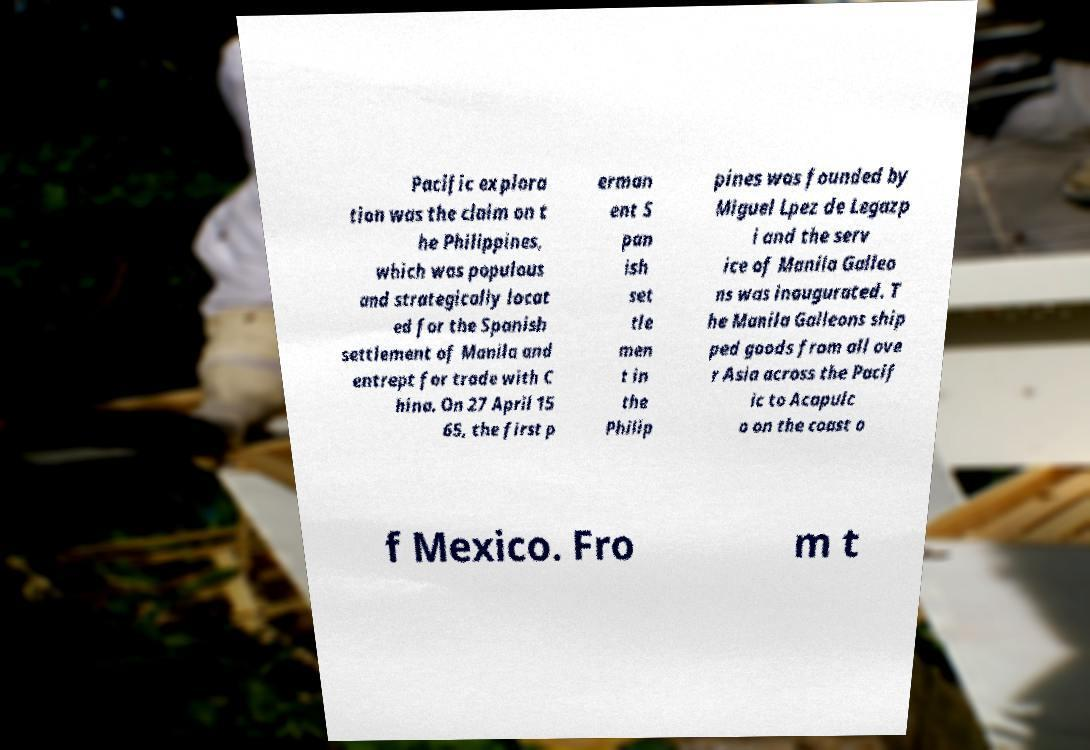Could you extract and type out the text from this image? Pacific explora tion was the claim on t he Philippines, which was populous and strategically locat ed for the Spanish settlement of Manila and entrept for trade with C hina. On 27 April 15 65, the first p erman ent S pan ish set tle men t in the Philip pines was founded by Miguel Lpez de Legazp i and the serv ice of Manila Galleo ns was inaugurated. T he Manila Galleons ship ped goods from all ove r Asia across the Pacif ic to Acapulc o on the coast o f Mexico. Fro m t 